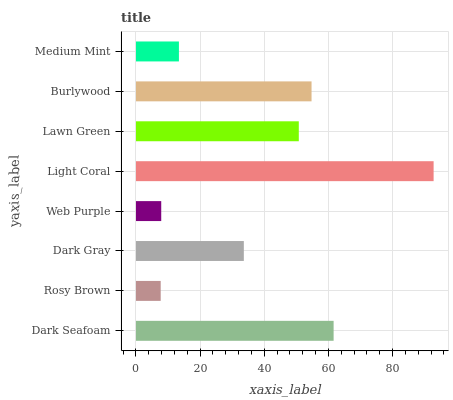Is Rosy Brown the minimum?
Answer yes or no. Yes. Is Light Coral the maximum?
Answer yes or no. Yes. Is Dark Gray the minimum?
Answer yes or no. No. Is Dark Gray the maximum?
Answer yes or no. No. Is Dark Gray greater than Rosy Brown?
Answer yes or no. Yes. Is Rosy Brown less than Dark Gray?
Answer yes or no. Yes. Is Rosy Brown greater than Dark Gray?
Answer yes or no. No. Is Dark Gray less than Rosy Brown?
Answer yes or no. No. Is Lawn Green the high median?
Answer yes or no. Yes. Is Dark Gray the low median?
Answer yes or no. Yes. Is Dark Seafoam the high median?
Answer yes or no. No. Is Medium Mint the low median?
Answer yes or no. No. 